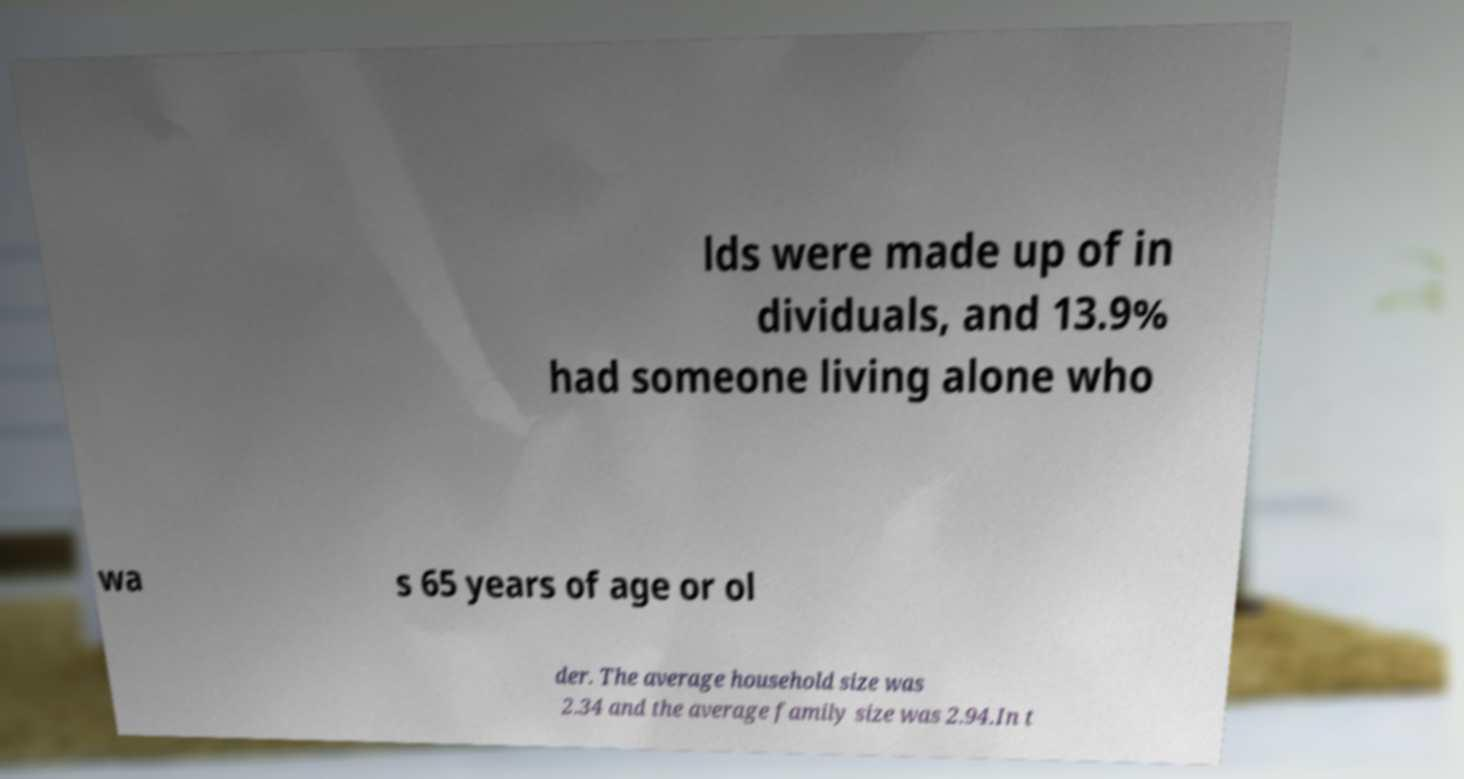Could you assist in decoding the text presented in this image and type it out clearly? lds were made up of in dividuals, and 13.9% had someone living alone who wa s 65 years of age or ol der. The average household size was 2.34 and the average family size was 2.94.In t 